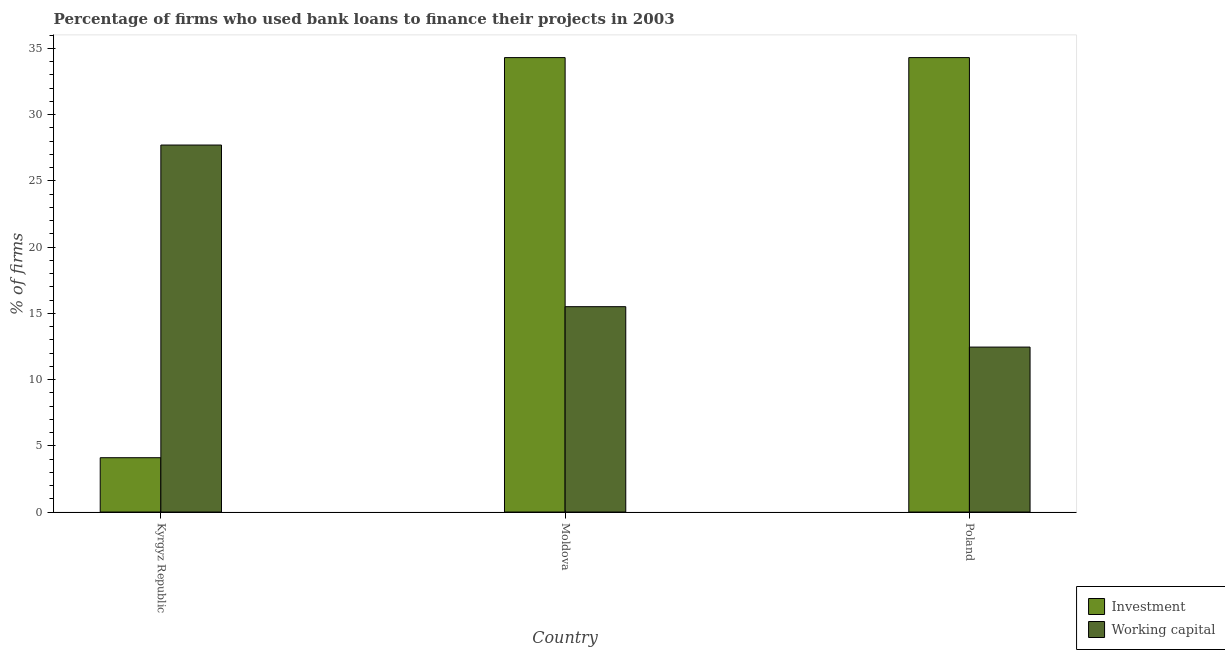Are the number of bars on each tick of the X-axis equal?
Make the answer very short. Yes. What is the label of the 1st group of bars from the left?
Offer a very short reply. Kyrgyz Republic. In how many cases, is the number of bars for a given country not equal to the number of legend labels?
Your answer should be compact. 0. What is the percentage of firms using banks to finance working capital in Moldova?
Provide a succinct answer. 15.5. Across all countries, what is the maximum percentage of firms using banks to finance working capital?
Your answer should be very brief. 27.7. Across all countries, what is the minimum percentage of firms using banks to finance investment?
Offer a very short reply. 4.1. In which country was the percentage of firms using banks to finance working capital maximum?
Ensure brevity in your answer.  Kyrgyz Republic. In which country was the percentage of firms using banks to finance working capital minimum?
Provide a short and direct response. Poland. What is the total percentage of firms using banks to finance investment in the graph?
Make the answer very short. 72.7. What is the difference between the percentage of firms using banks to finance working capital in Moldova and that in Poland?
Provide a short and direct response. 3.05. What is the difference between the percentage of firms using banks to finance investment in Poland and the percentage of firms using banks to finance working capital in Kyrgyz Republic?
Provide a succinct answer. 6.6. What is the average percentage of firms using banks to finance working capital per country?
Keep it short and to the point. 18.55. What is the difference between the percentage of firms using banks to finance working capital and percentage of firms using banks to finance investment in Moldova?
Ensure brevity in your answer.  -18.8. Is the difference between the percentage of firms using banks to finance working capital in Kyrgyz Republic and Moldova greater than the difference between the percentage of firms using banks to finance investment in Kyrgyz Republic and Moldova?
Ensure brevity in your answer.  Yes. What is the difference between the highest and the second highest percentage of firms using banks to finance investment?
Your answer should be very brief. 0. What is the difference between the highest and the lowest percentage of firms using banks to finance working capital?
Your response must be concise. 15.25. In how many countries, is the percentage of firms using banks to finance investment greater than the average percentage of firms using banks to finance investment taken over all countries?
Ensure brevity in your answer.  2. What does the 2nd bar from the left in Kyrgyz Republic represents?
Your answer should be very brief. Working capital. What does the 1st bar from the right in Moldova represents?
Your answer should be very brief. Working capital. How many bars are there?
Your answer should be compact. 6. Are all the bars in the graph horizontal?
Offer a very short reply. No. Does the graph contain any zero values?
Your answer should be compact. No. Where does the legend appear in the graph?
Make the answer very short. Bottom right. How are the legend labels stacked?
Your answer should be compact. Vertical. What is the title of the graph?
Give a very brief answer. Percentage of firms who used bank loans to finance their projects in 2003. Does "Secondary Education" appear as one of the legend labels in the graph?
Offer a terse response. No. What is the label or title of the X-axis?
Give a very brief answer. Country. What is the label or title of the Y-axis?
Make the answer very short. % of firms. What is the % of firms of Investment in Kyrgyz Republic?
Offer a very short reply. 4.1. What is the % of firms of Working capital in Kyrgyz Republic?
Ensure brevity in your answer.  27.7. What is the % of firms of Investment in Moldova?
Your answer should be compact. 34.3. What is the % of firms in Working capital in Moldova?
Your answer should be compact. 15.5. What is the % of firms of Investment in Poland?
Provide a short and direct response. 34.3. What is the % of firms in Working capital in Poland?
Give a very brief answer. 12.45. Across all countries, what is the maximum % of firms in Investment?
Give a very brief answer. 34.3. Across all countries, what is the maximum % of firms of Working capital?
Your response must be concise. 27.7. Across all countries, what is the minimum % of firms in Investment?
Provide a short and direct response. 4.1. Across all countries, what is the minimum % of firms in Working capital?
Offer a terse response. 12.45. What is the total % of firms of Investment in the graph?
Give a very brief answer. 72.7. What is the total % of firms in Working capital in the graph?
Offer a terse response. 55.65. What is the difference between the % of firms of Investment in Kyrgyz Republic and that in Moldova?
Provide a short and direct response. -30.2. What is the difference between the % of firms in Working capital in Kyrgyz Republic and that in Moldova?
Offer a very short reply. 12.2. What is the difference between the % of firms in Investment in Kyrgyz Republic and that in Poland?
Give a very brief answer. -30.2. What is the difference between the % of firms of Working capital in Kyrgyz Republic and that in Poland?
Offer a terse response. 15.25. What is the difference between the % of firms in Investment in Moldova and that in Poland?
Your answer should be compact. 0. What is the difference between the % of firms of Working capital in Moldova and that in Poland?
Offer a terse response. 3.05. What is the difference between the % of firms of Investment in Kyrgyz Republic and the % of firms of Working capital in Moldova?
Your response must be concise. -11.4. What is the difference between the % of firms in Investment in Kyrgyz Republic and the % of firms in Working capital in Poland?
Ensure brevity in your answer.  -8.35. What is the difference between the % of firms of Investment in Moldova and the % of firms of Working capital in Poland?
Your response must be concise. 21.85. What is the average % of firms in Investment per country?
Provide a succinct answer. 24.23. What is the average % of firms of Working capital per country?
Give a very brief answer. 18.55. What is the difference between the % of firms of Investment and % of firms of Working capital in Kyrgyz Republic?
Offer a very short reply. -23.6. What is the difference between the % of firms in Investment and % of firms in Working capital in Moldova?
Ensure brevity in your answer.  18.8. What is the difference between the % of firms of Investment and % of firms of Working capital in Poland?
Your answer should be very brief. 21.85. What is the ratio of the % of firms in Investment in Kyrgyz Republic to that in Moldova?
Your answer should be compact. 0.12. What is the ratio of the % of firms in Working capital in Kyrgyz Republic to that in Moldova?
Provide a short and direct response. 1.79. What is the ratio of the % of firms in Investment in Kyrgyz Republic to that in Poland?
Offer a terse response. 0.12. What is the ratio of the % of firms of Working capital in Kyrgyz Republic to that in Poland?
Your answer should be very brief. 2.22. What is the ratio of the % of firms in Working capital in Moldova to that in Poland?
Your answer should be compact. 1.25. What is the difference between the highest and the second highest % of firms in Working capital?
Keep it short and to the point. 12.2. What is the difference between the highest and the lowest % of firms in Investment?
Provide a succinct answer. 30.2. What is the difference between the highest and the lowest % of firms in Working capital?
Make the answer very short. 15.25. 